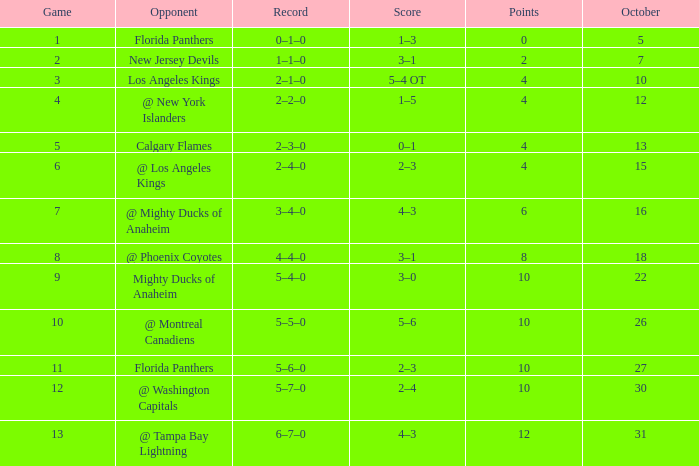What team has a score of 11 5–6–0. 